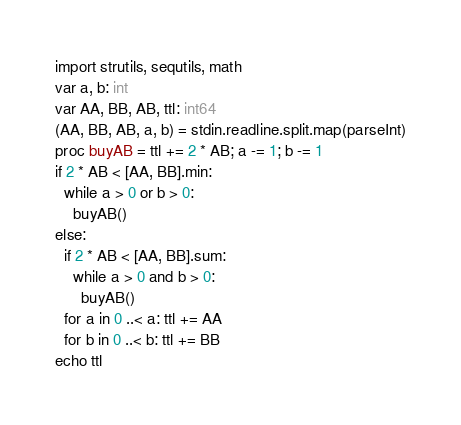<code> <loc_0><loc_0><loc_500><loc_500><_Nim_>import strutils, sequtils, math
var a, b: int
var AA, BB, AB, ttl: int64
(AA, BB, AB, a, b) = stdin.readline.split.map(parseInt)
proc buyAB = ttl += 2 * AB; a -= 1; b -= 1
if 2 * AB < [AA, BB].min:
  while a > 0 or b > 0:
    buyAB()
else:
  if 2 * AB < [AA, BB].sum:
    while a > 0 and b > 0:
      buyAB()
  for a in 0 ..< a: ttl += AA
  for b in 0 ..< b: ttl += BB
echo ttl</code> 